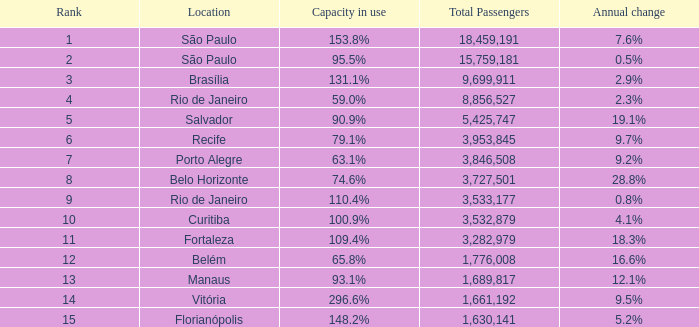What is the highest Total Passengers when the annual change is 18.3%, and the rank is less than 11? None. 